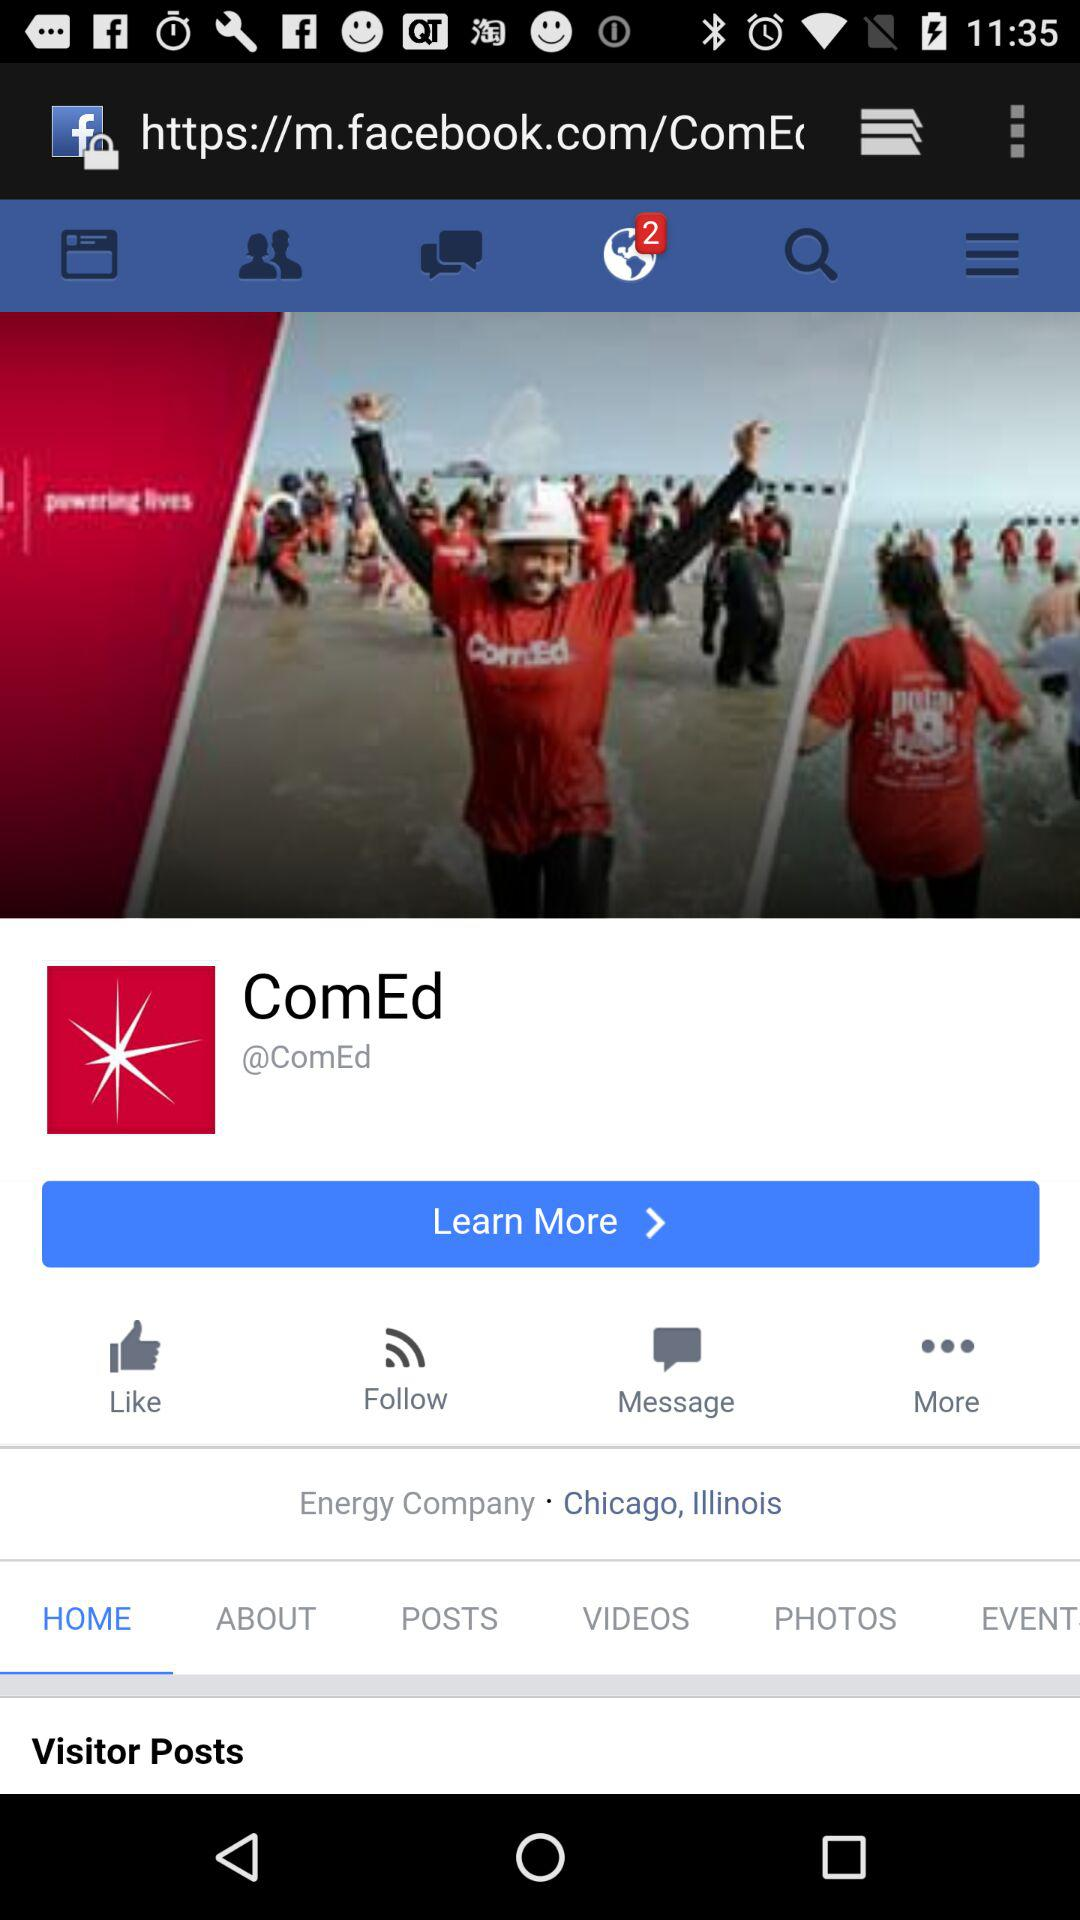Is there any notifications pending?
When the provided information is insufficient, respond with <no answer>. <no answer> 